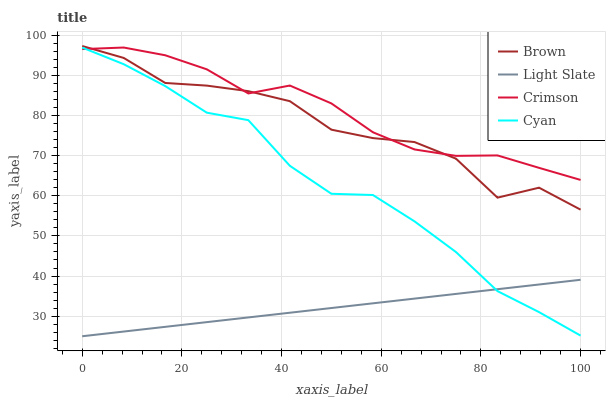Does Brown have the minimum area under the curve?
Answer yes or no. No. Does Brown have the maximum area under the curve?
Answer yes or no. No. Is Crimson the smoothest?
Answer yes or no. No. Is Crimson the roughest?
Answer yes or no. No. Does Brown have the lowest value?
Answer yes or no. No. Does Crimson have the highest value?
Answer yes or no. No. Is Light Slate less than Brown?
Answer yes or no. Yes. Is Brown greater than Light Slate?
Answer yes or no. Yes. Does Light Slate intersect Brown?
Answer yes or no. No. 